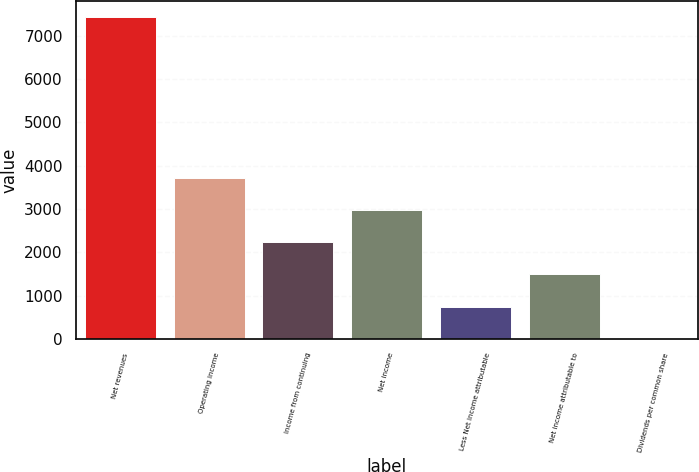Convert chart to OTSL. <chart><loc_0><loc_0><loc_500><loc_500><bar_chart><fcel>Net revenues<fcel>Operating income<fcel>Income from continuing<fcel>Net income<fcel>Less Net income attributable<fcel>Net income attributable to<fcel>Dividends per common share<nl><fcel>7435<fcel>3718.17<fcel>2231.43<fcel>2974.8<fcel>744.69<fcel>1488.06<fcel>1.32<nl></chart> 